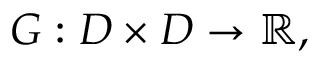<formula> <loc_0><loc_0><loc_500><loc_500>G \colon D \times D \to \mathbb { R } ,</formula> 